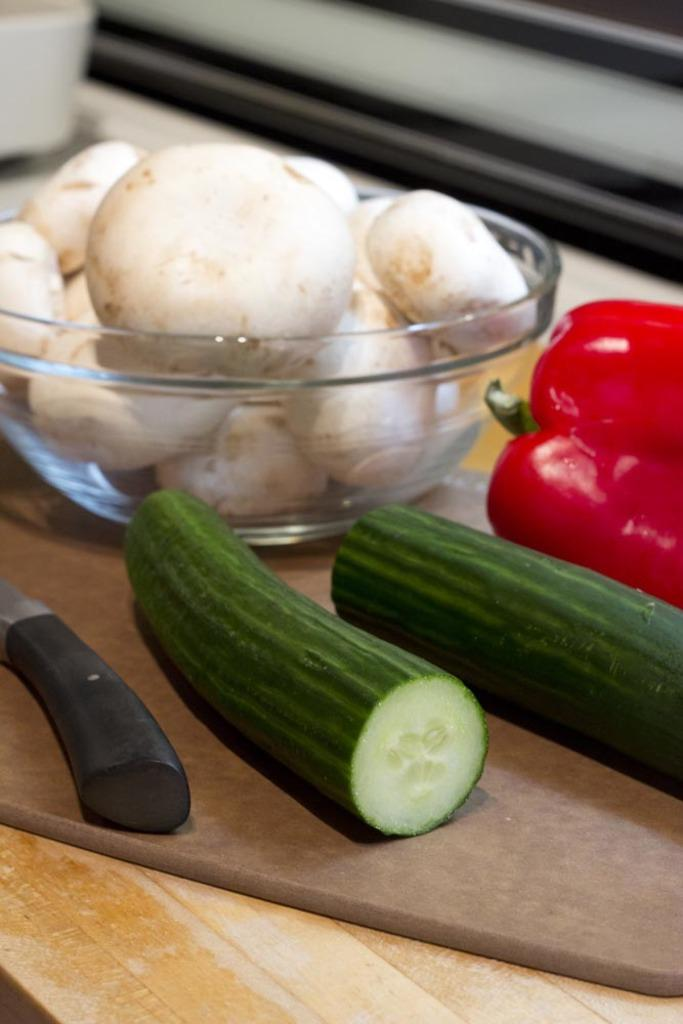What type of food items are present in the image? There are vegetables in the image. How are the vegetables arranged in the image? The vegetables are placed in a bowl and on a table. What colors can be seen among the vegetables in the image? The vegetables have white, red, and green colors. Can you describe the background of the image? The background of the image is blurred. What type of religious symbol can be seen near the vegetables in the image? There is no religious symbol present in the image; it only features vegetables in a bowl and on a table. 